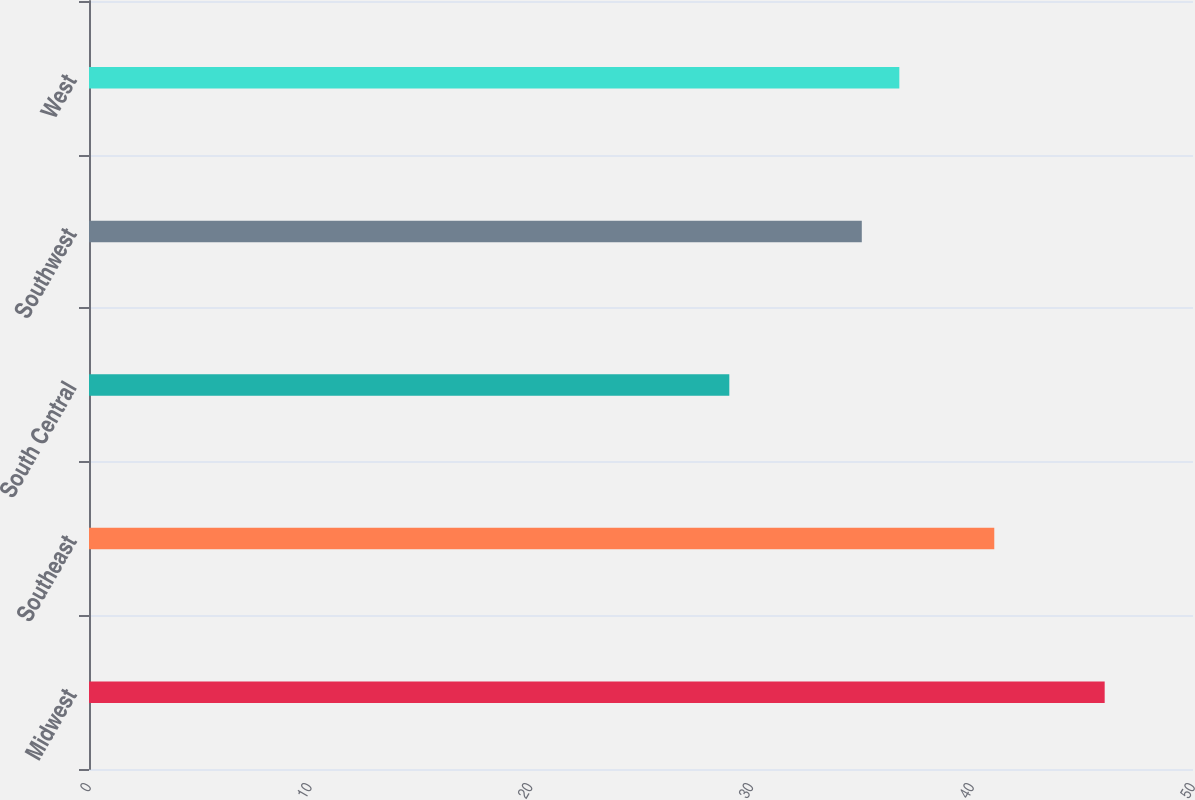Convert chart to OTSL. <chart><loc_0><loc_0><loc_500><loc_500><bar_chart><fcel>Midwest<fcel>Southeast<fcel>South Central<fcel>Southwest<fcel>West<nl><fcel>46<fcel>41<fcel>29<fcel>35<fcel>36.7<nl></chart> 